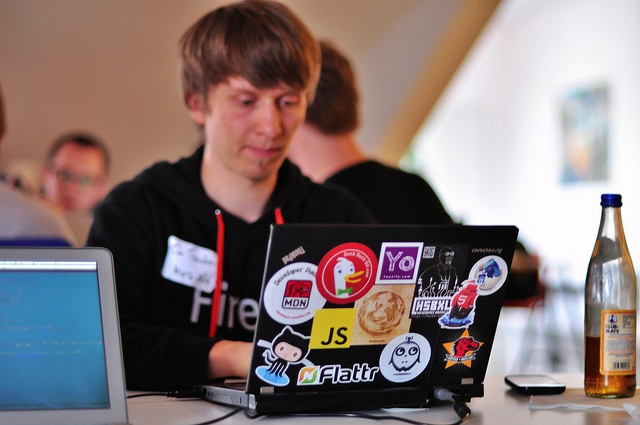Describe the objects in this image and their specific colors. I can see people in gray, black, maroon, brown, and salmon tones, laptop in gray, black, lavender, and darkgray tones, laptop in gray and teal tones, people in gray, black, maroon, brown, and salmon tones, and bottle in gray, darkgray, and black tones in this image. 